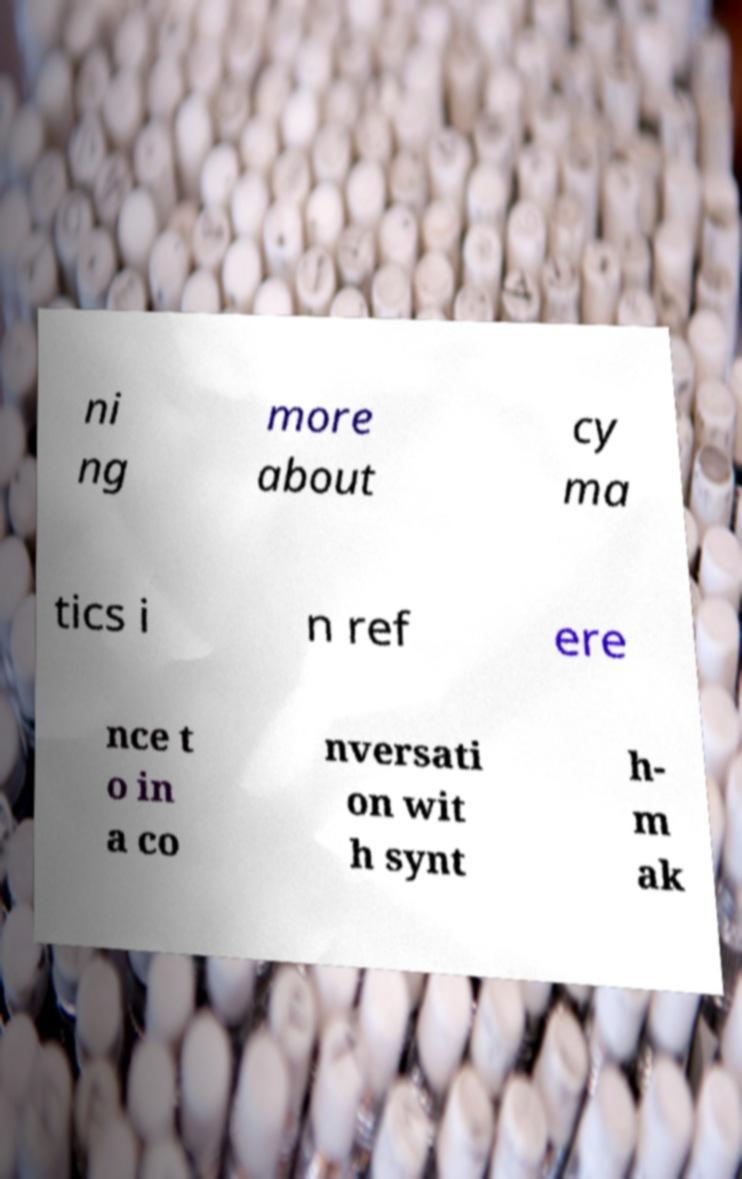What messages or text are displayed in this image? I need them in a readable, typed format. ni ng more about cy ma tics i n ref ere nce t o in a co nversati on wit h synt h- m ak 